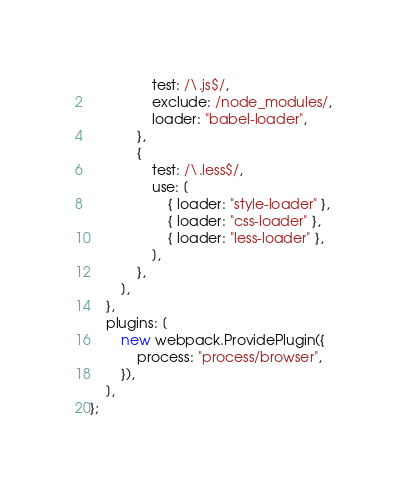Convert code to text. <code><loc_0><loc_0><loc_500><loc_500><_JavaScript_>                test: /\.js$/,
                exclude: /node_modules/,
                loader: "babel-loader",
            },
            {
                test: /\.less$/,
                use: [
                    { loader: "style-loader" },
                    { loader: "css-loader" },
                    { loader: "less-loader" },
                ],
            },
        ],
    },
    plugins: [
        new webpack.ProvidePlugin({
            process: "process/browser",
        }),
    ],
};
</code> 